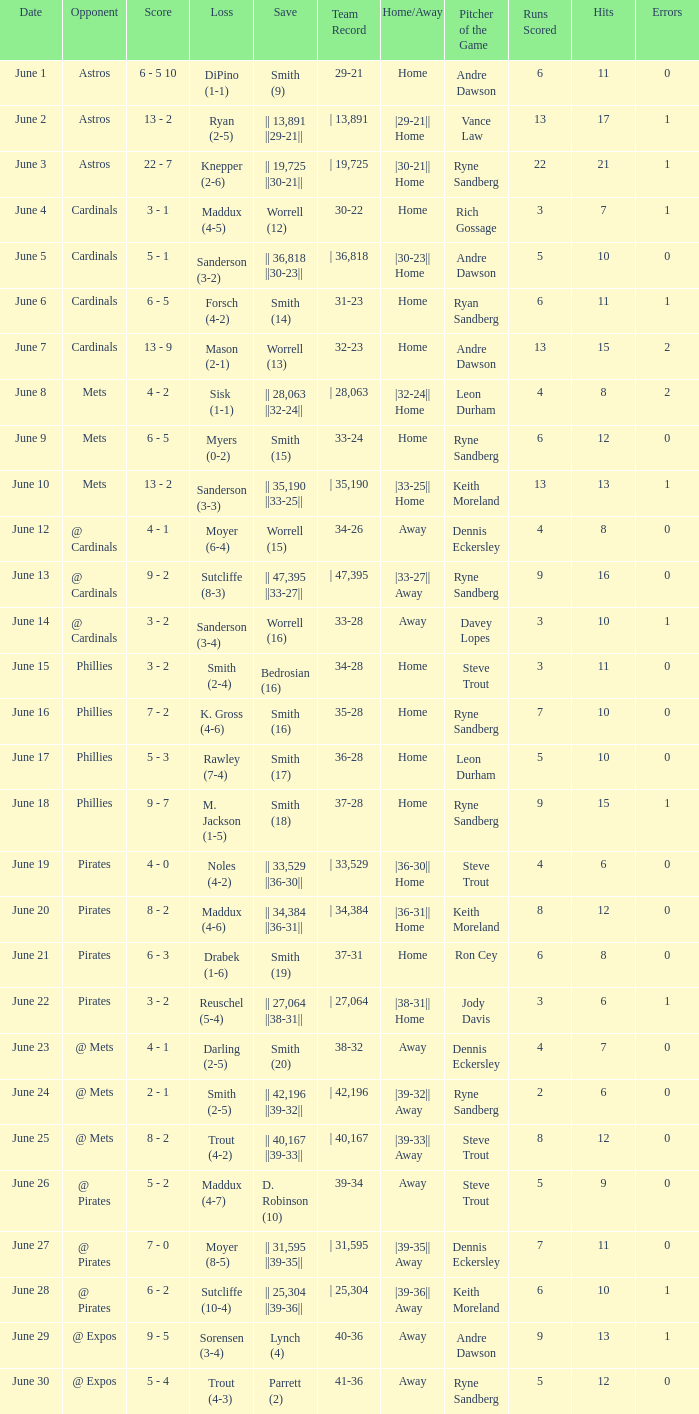What is the setback for the game versus @ expos, with a save of parrett (2)? Trout (4-3). 